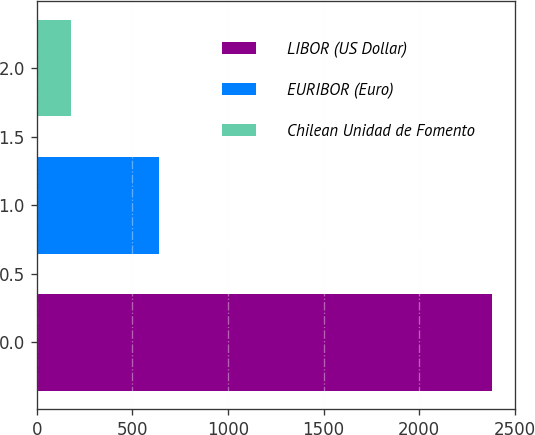Convert chart. <chart><loc_0><loc_0><loc_500><loc_500><bar_chart><fcel>LIBOR (US Dollar)<fcel>EURIBOR (Euro)<fcel>Chilean Unidad de Fomento<nl><fcel>2382<fcel>642<fcel>179<nl></chart> 